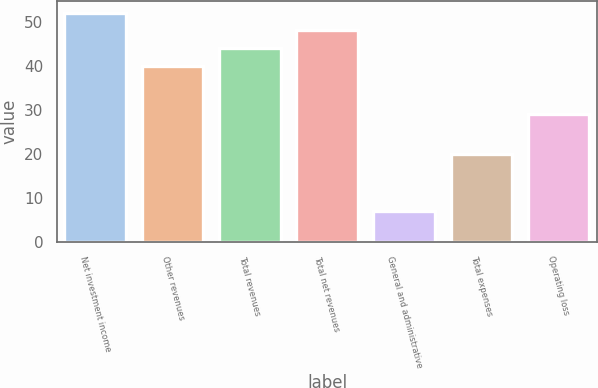<chart> <loc_0><loc_0><loc_500><loc_500><bar_chart><fcel>Net investment income<fcel>Other revenues<fcel>Total revenues<fcel>Total net revenues<fcel>General and administrative<fcel>Total expenses<fcel>Operating loss<nl><fcel>52<fcel>40<fcel>44<fcel>48<fcel>7<fcel>20<fcel>29<nl></chart> 